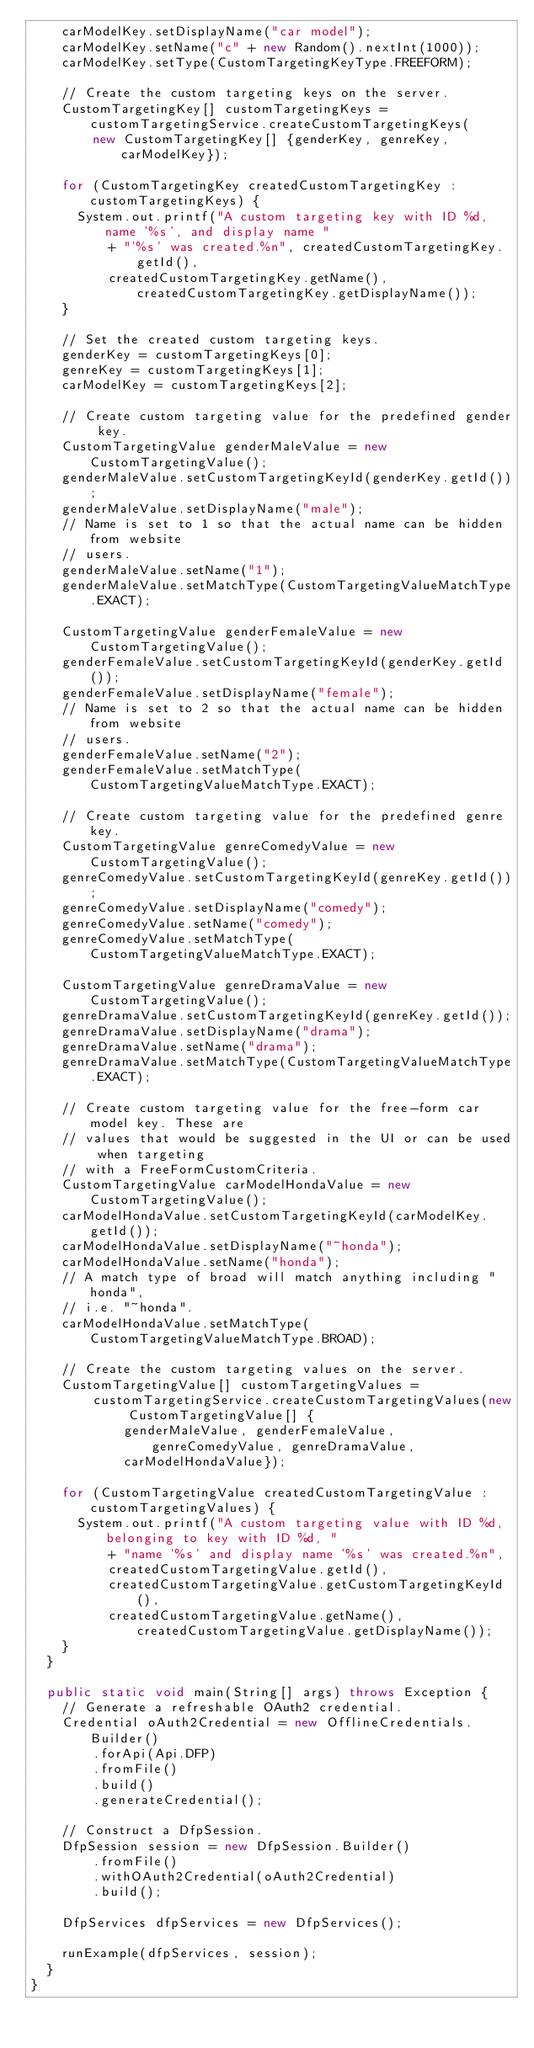Convert code to text. <code><loc_0><loc_0><loc_500><loc_500><_Java_>    carModelKey.setDisplayName("car model");
    carModelKey.setName("c" + new Random().nextInt(1000));
    carModelKey.setType(CustomTargetingKeyType.FREEFORM);

    // Create the custom targeting keys on the server.
    CustomTargetingKey[] customTargetingKeys = customTargetingService.createCustomTargetingKeys(
        new CustomTargetingKey[] {genderKey, genreKey, carModelKey});

    for (CustomTargetingKey createdCustomTargetingKey : customTargetingKeys) {
      System.out.printf("A custom targeting key with ID %d, name '%s', and display name "
          + "'%s' was created.%n", createdCustomTargetingKey.getId(),
          createdCustomTargetingKey.getName(), createdCustomTargetingKey.getDisplayName());
    }

    // Set the created custom targeting keys.
    genderKey = customTargetingKeys[0];
    genreKey = customTargetingKeys[1];
    carModelKey = customTargetingKeys[2];

    // Create custom targeting value for the predefined gender key.
    CustomTargetingValue genderMaleValue = new CustomTargetingValue();
    genderMaleValue.setCustomTargetingKeyId(genderKey.getId());
    genderMaleValue.setDisplayName("male");
    // Name is set to 1 so that the actual name can be hidden from website
    // users.
    genderMaleValue.setName("1");
    genderMaleValue.setMatchType(CustomTargetingValueMatchType.EXACT);

    CustomTargetingValue genderFemaleValue = new CustomTargetingValue();
    genderFemaleValue.setCustomTargetingKeyId(genderKey.getId());
    genderFemaleValue.setDisplayName("female");
    // Name is set to 2 so that the actual name can be hidden from website
    // users.
    genderFemaleValue.setName("2");
    genderFemaleValue.setMatchType(CustomTargetingValueMatchType.EXACT);

    // Create custom targeting value for the predefined genre key.
    CustomTargetingValue genreComedyValue = new CustomTargetingValue();
    genreComedyValue.setCustomTargetingKeyId(genreKey.getId());
    genreComedyValue.setDisplayName("comedy");
    genreComedyValue.setName("comedy");
    genreComedyValue.setMatchType(CustomTargetingValueMatchType.EXACT);

    CustomTargetingValue genreDramaValue = new CustomTargetingValue();
    genreDramaValue.setCustomTargetingKeyId(genreKey.getId());
    genreDramaValue.setDisplayName("drama");
    genreDramaValue.setName("drama");
    genreDramaValue.setMatchType(CustomTargetingValueMatchType.EXACT);

    // Create custom targeting value for the free-form car model key. These are
    // values that would be suggested in the UI or can be used when targeting
    // with a FreeFormCustomCriteria.
    CustomTargetingValue carModelHondaValue = new CustomTargetingValue();
    carModelHondaValue.setCustomTargetingKeyId(carModelKey.getId());
    carModelHondaValue.setDisplayName("~honda");
    carModelHondaValue.setName("honda");
    // A match type of broad will match anything including "honda",
    // i.e. "~honda".
    carModelHondaValue.setMatchType(CustomTargetingValueMatchType.BROAD);

    // Create the custom targeting values on the server.
    CustomTargetingValue[] customTargetingValues =
        customTargetingService.createCustomTargetingValues(new CustomTargetingValue[] {
            genderMaleValue, genderFemaleValue, genreComedyValue, genreDramaValue,
            carModelHondaValue});

    for (CustomTargetingValue createdCustomTargetingValue : customTargetingValues) {
      System.out.printf("A custom targeting value with ID %d, belonging to key with ID %d, "
          + "name '%s' and display name '%s' was created.%n",
          createdCustomTargetingValue.getId(),
          createdCustomTargetingValue.getCustomTargetingKeyId(),
          createdCustomTargetingValue.getName(), createdCustomTargetingValue.getDisplayName());
    }
  }

  public static void main(String[] args) throws Exception {
    // Generate a refreshable OAuth2 credential.
    Credential oAuth2Credential = new OfflineCredentials.Builder()
        .forApi(Api.DFP)
        .fromFile()
        .build()
        .generateCredential();

    // Construct a DfpSession.
    DfpSession session = new DfpSession.Builder()
        .fromFile()
        .withOAuth2Credential(oAuth2Credential)
        .build();

    DfpServices dfpServices = new DfpServices();

    runExample(dfpServices, session);
  }
}
</code> 